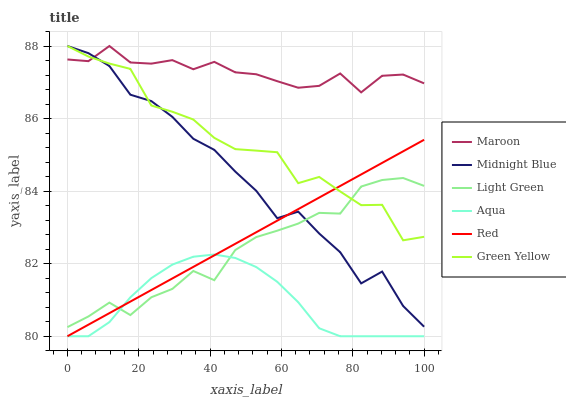Does Maroon have the minimum area under the curve?
Answer yes or no. No. Does Aqua have the maximum area under the curve?
Answer yes or no. No. Is Aqua the smoothest?
Answer yes or no. No. Is Aqua the roughest?
Answer yes or no. No. Does Maroon have the lowest value?
Answer yes or no. No. Does Aqua have the highest value?
Answer yes or no. No. Is Light Green less than Maroon?
Answer yes or no. Yes. Is Maroon greater than Aqua?
Answer yes or no. Yes. Does Light Green intersect Maroon?
Answer yes or no. No. 